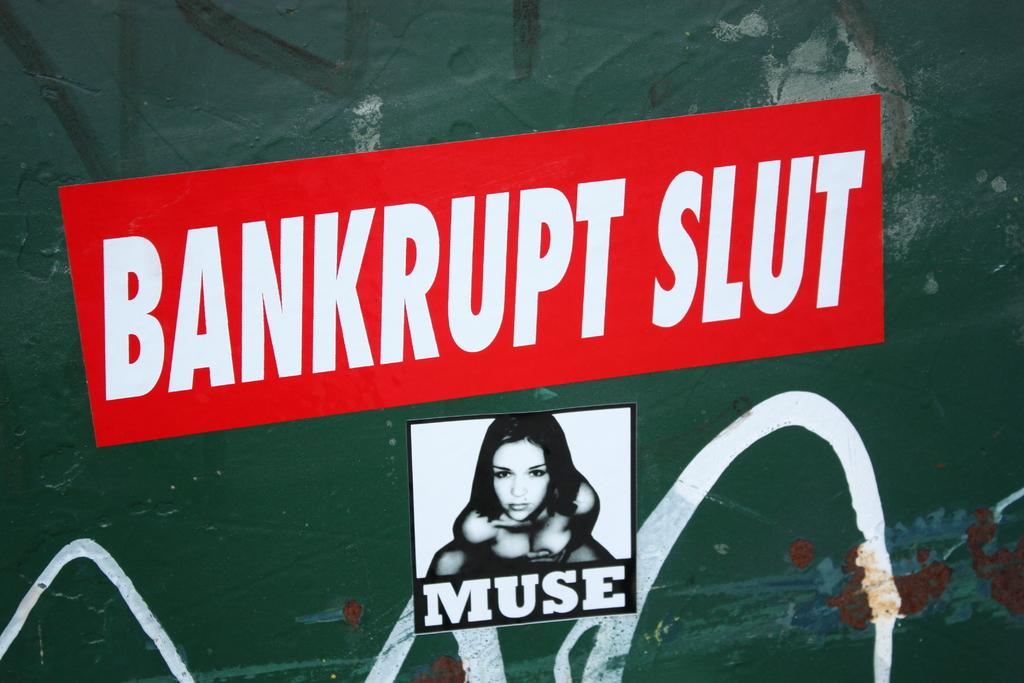<image>
Present a compact description of the photo's key features. A sticker of a girl posing with the word Muse below it 